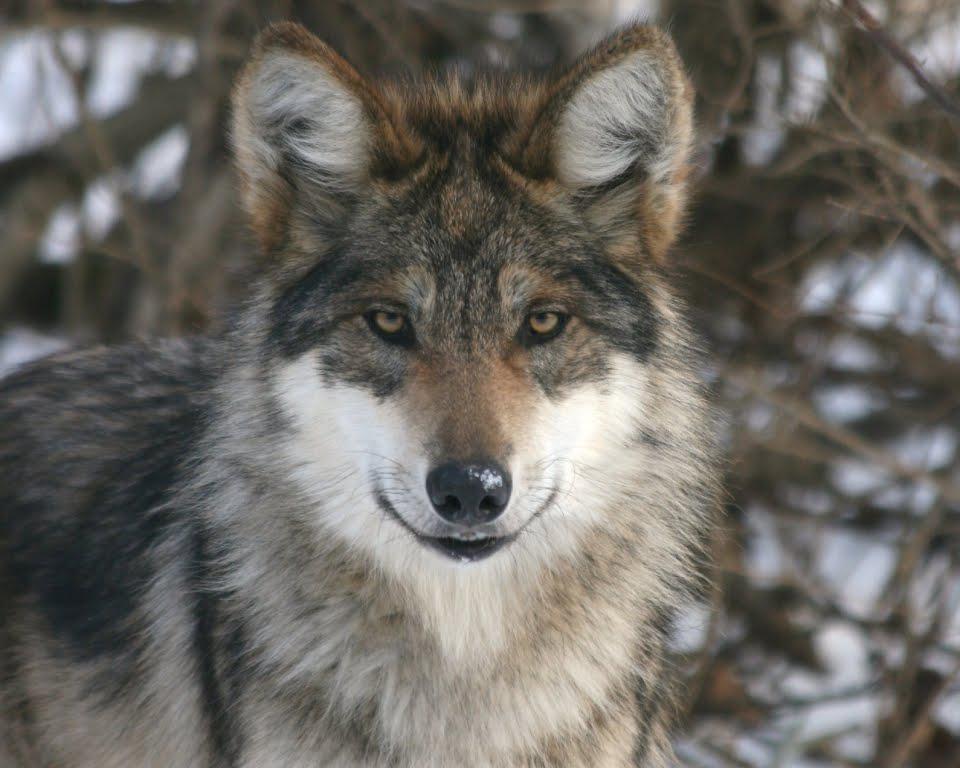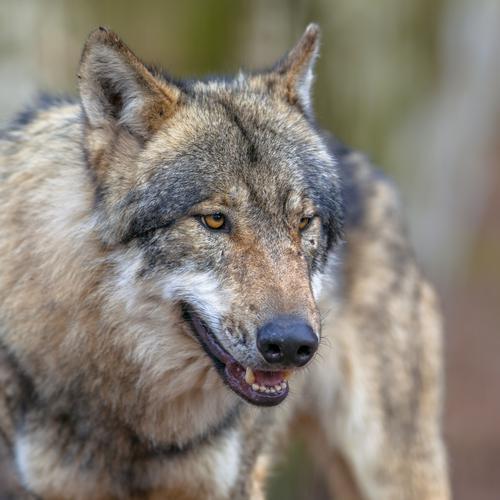The first image is the image on the left, the second image is the image on the right. Examine the images to the left and right. Is the description "The image on the left contains one more wolf than the image on the right." accurate? Answer yes or no. No. The first image is the image on the left, the second image is the image on the right. Assess this claim about the two images: "There are at least three wolves.". Correct or not? Answer yes or no. No. 